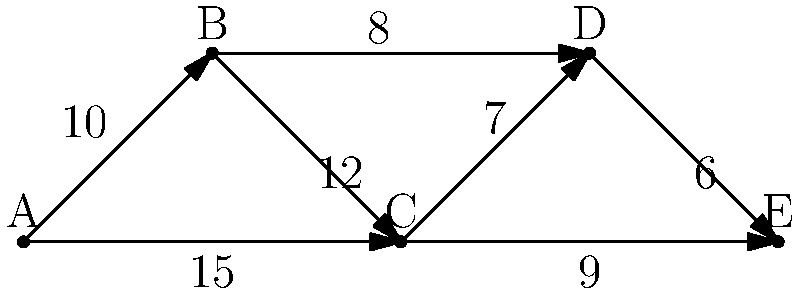As a sports camp organizer, you need to plan the most efficient transportation route for a team visiting multiple venues. Given the network diagram above, where each node represents a venue (A is the starting point, and E is the final destination) and the edges represent roads with their respective distances in miles, what is the shortest possible route from A to E? To find the shortest path from A to E, we'll use Dijkstra's algorithm:

1. Initialize:
   - Distance to A = 0
   - Distance to all other nodes = infinity
   - Set of unvisited nodes = {A, B, C, D, E}

2. From A:
   - A to B: 10 miles
   - A to C: 15 miles
   - Update distances: A(0), B(10), C(15), D(∞), E(∞)

3. Visit B (shortest unvisited):
   - B to C: 10 + 12 = 22 > 15, no update
   - B to D: 10 + 8 = 18
   - Update distances: A(0), B(10), C(15), D(18), E(∞)

4. Visit C:
   - C to D: 15 + 7 = 22 > 18, no update
   - C to E: 15 + 9 = 24
   - Update distances: A(0), B(10), C(15), D(18), E(24)

5. Visit D:
   - D to E: 18 + 6 = 24 = current E, no update

6. Visit E (final destination reached)

The shortest path is A → B → D → E, with a total distance of 24 miles.
Answer: A → B → D → E (24 miles) 